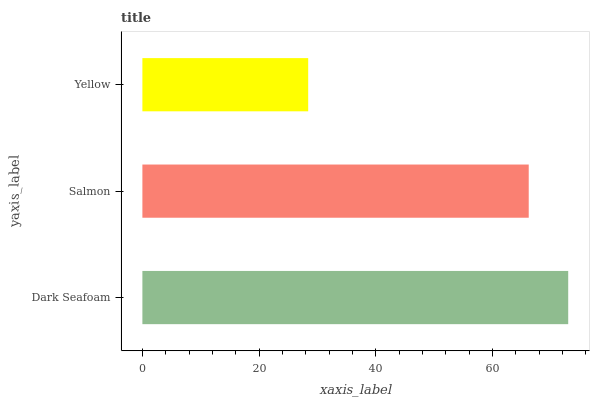Is Yellow the minimum?
Answer yes or no. Yes. Is Dark Seafoam the maximum?
Answer yes or no. Yes. Is Salmon the minimum?
Answer yes or no. No. Is Salmon the maximum?
Answer yes or no. No. Is Dark Seafoam greater than Salmon?
Answer yes or no. Yes. Is Salmon less than Dark Seafoam?
Answer yes or no. Yes. Is Salmon greater than Dark Seafoam?
Answer yes or no. No. Is Dark Seafoam less than Salmon?
Answer yes or no. No. Is Salmon the high median?
Answer yes or no. Yes. Is Salmon the low median?
Answer yes or no. Yes. Is Yellow the high median?
Answer yes or no. No. Is Dark Seafoam the low median?
Answer yes or no. No. 